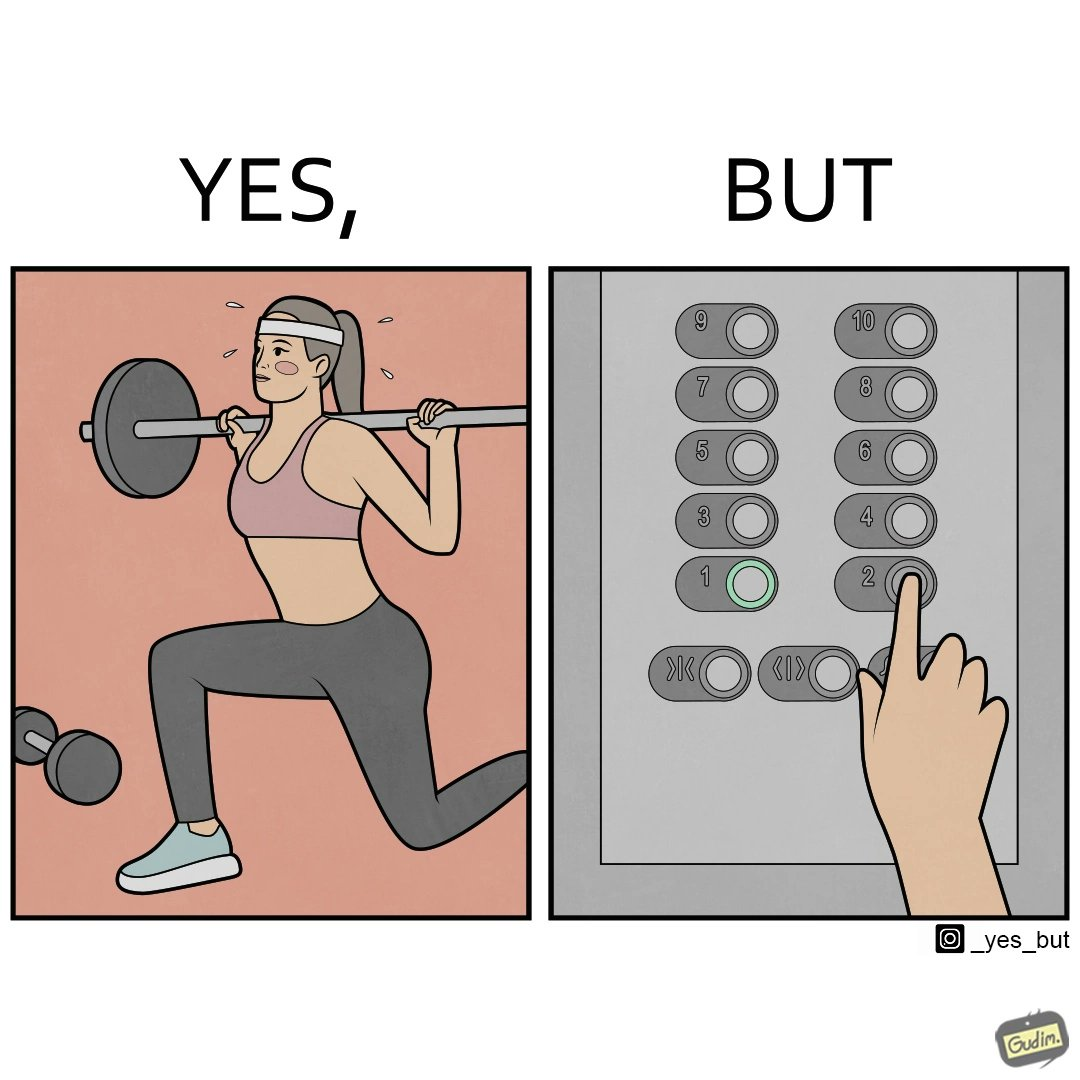Is this image satirical or non-satirical? Yes, this image is satirical. 